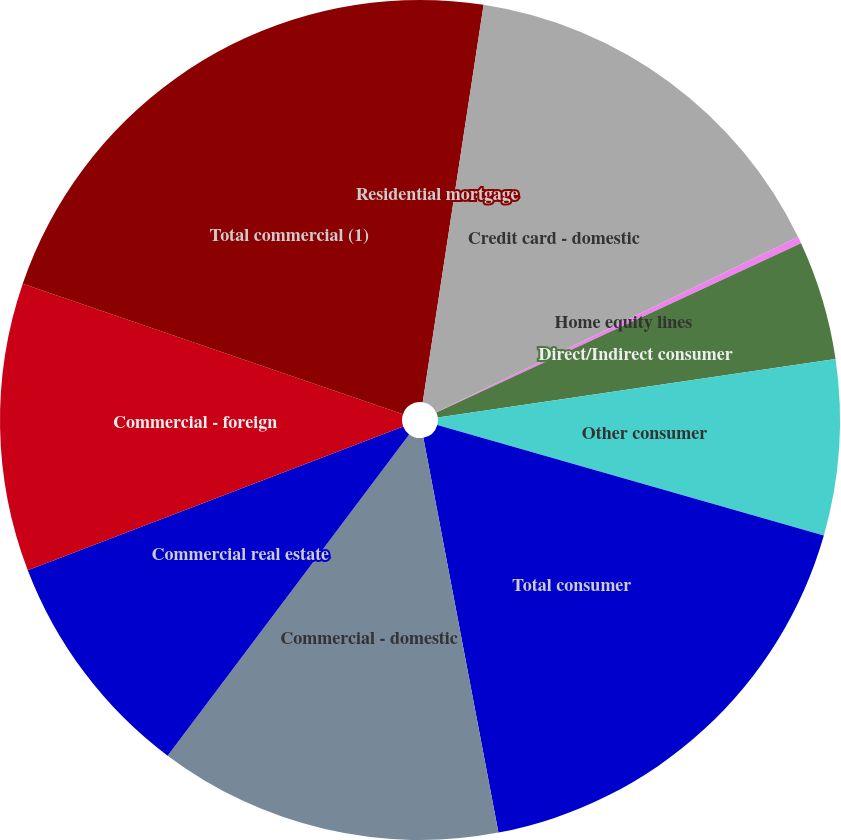Convert chart. <chart><loc_0><loc_0><loc_500><loc_500><pie_chart><fcel>Residential mortgage<fcel>Credit card - domestic<fcel>Home equity lines<fcel>Direct/Indirect consumer<fcel>Other consumer<fcel>Total consumer<fcel>Commercial - domestic<fcel>Commercial real estate<fcel>Commercial - foreign<fcel>Total commercial (1)<nl><fcel>2.42%<fcel>15.41%<fcel>0.26%<fcel>4.59%<fcel>6.75%<fcel>17.58%<fcel>13.25%<fcel>8.92%<fcel>11.08%<fcel>19.74%<nl></chart> 